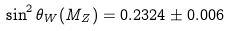<formula> <loc_0><loc_0><loc_500><loc_500>\sin ^ { 2 } \theta _ { W } ( M _ { Z } ) = 0 . 2 3 2 4 \pm 0 . 0 0 6</formula> 